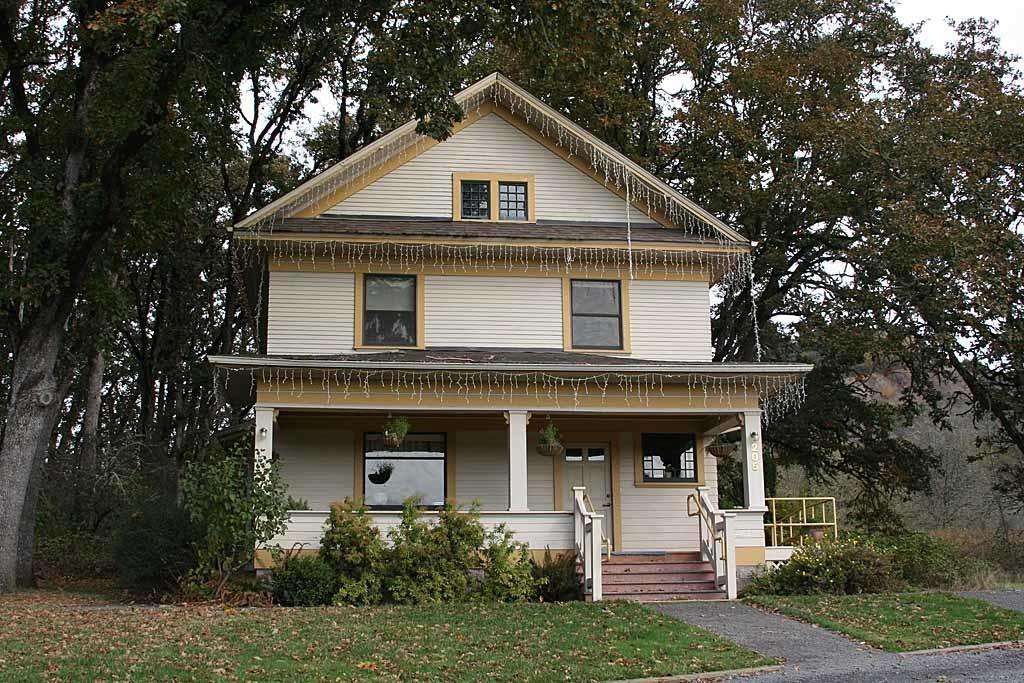What type of structure is visible in the image? There is a building in the image. What can be seen in the background of the image? There are trees and plants in the background of the image. Can you describe the architectural feature in the image? There is a staircase in the image. What is the ground surface like in the image? There is grass and dried leaves on the ground in the image. Is there a path visible in the image? Yes, there is a path in the image. What type of boat can be seen floating on the grass in the image? There is no boat present in the image; it features a building, trees, plants, a staircase, a path, grass, and dried leaves. 